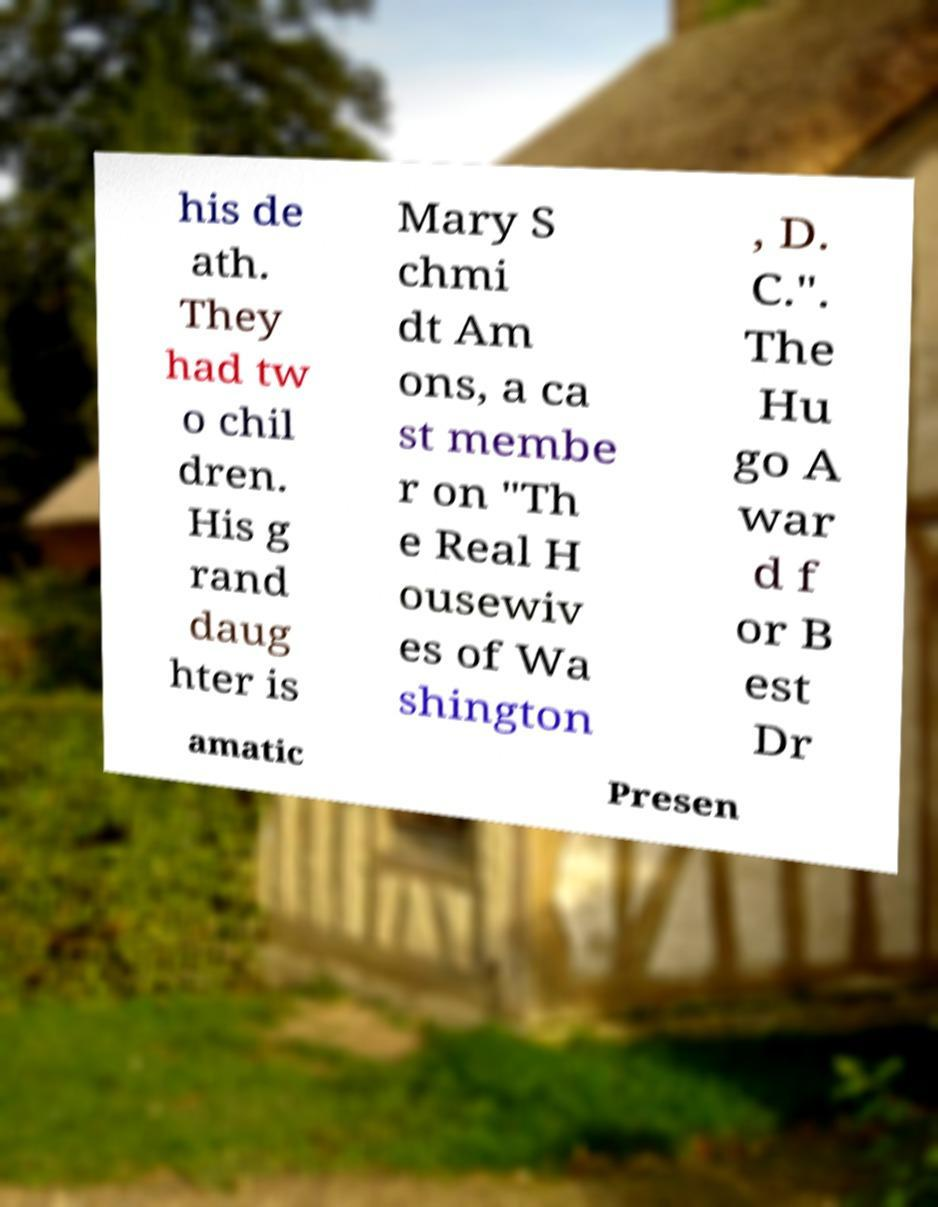Please identify and transcribe the text found in this image. his de ath. They had tw o chil dren. His g rand daug hter is Mary S chmi dt Am ons, a ca st membe r on "Th e Real H ousewiv es of Wa shington , D. C.". The Hu go A war d f or B est Dr amatic Presen 